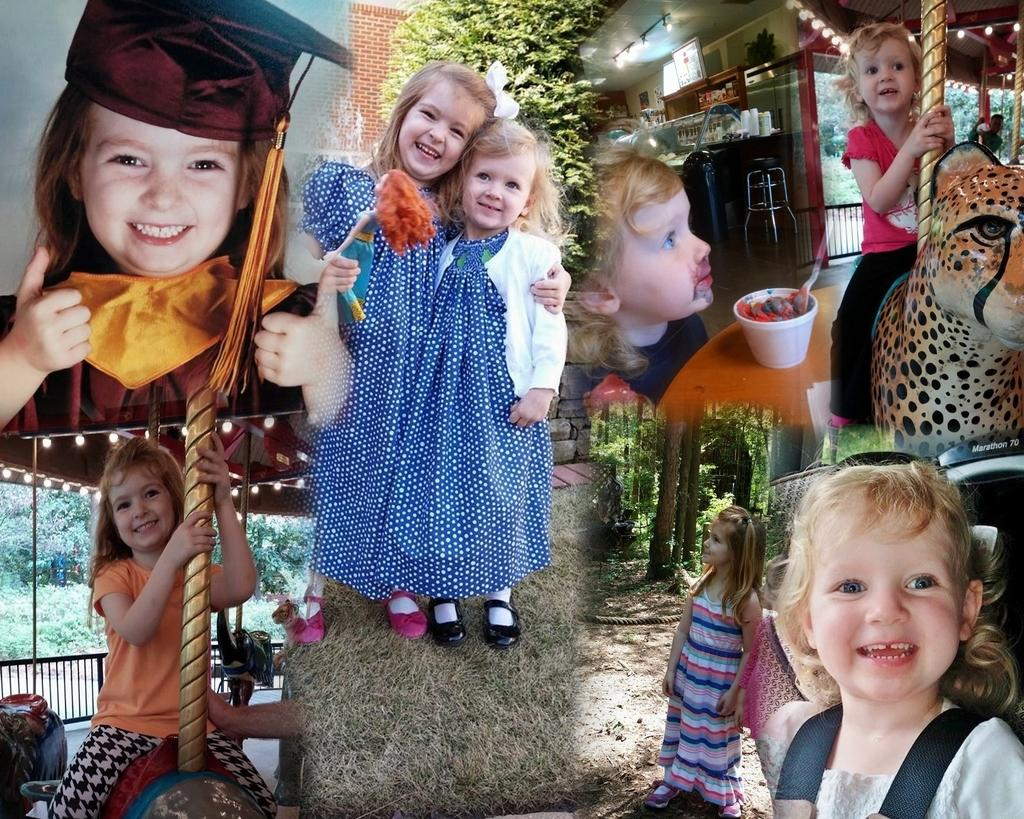What type of attractions can be seen in the image? There are fun rides in the image. Who can be seen enjoying the fun rides? Children are present in the image. What is located near the fun rides? There is a table in the image. What is placed on the table? A cup is visible in the image. What type of food items are present in the image? There are food items in the image. What utensils are used for eating the food items? Spoons are present in the image. What can be seen illuminating the area in the image? Lights are visible in the image. What type of structure can be seen in the background of the image? There is a wall in the image. What type of vegetation is present in the image? Bushes, trees, and grass are visible in the image. What type of material is used for the rope in the image? The rope in the image is made of a material that is not specified. What type of accessory is present in the image? A hat is present in the image. What type of goose is present in the image? There is no goose present in the image. What type of leather item can be seen in the image? There is no leather item present in the image. What type of pet is visible in the image? There is no pet visible in the image. 